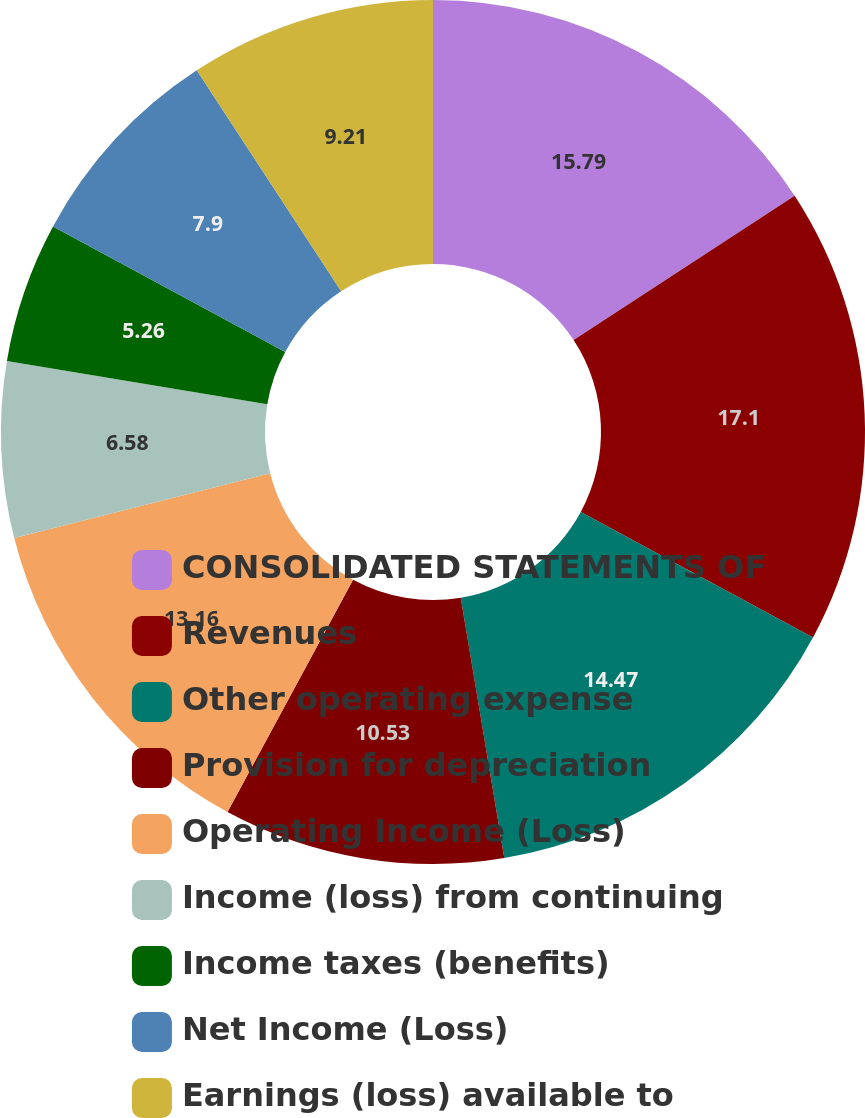Convert chart. <chart><loc_0><loc_0><loc_500><loc_500><pie_chart><fcel>CONSOLIDATED STATEMENTS OF<fcel>Revenues<fcel>Other operating expense<fcel>Provision for depreciation<fcel>Operating Income (Loss)<fcel>Income (loss) from continuing<fcel>Income taxes (benefits)<fcel>Net Income (Loss)<fcel>Earnings (loss) available to<nl><fcel>15.79%<fcel>17.1%<fcel>14.47%<fcel>10.53%<fcel>13.16%<fcel>6.58%<fcel>5.26%<fcel>7.9%<fcel>9.21%<nl></chart> 